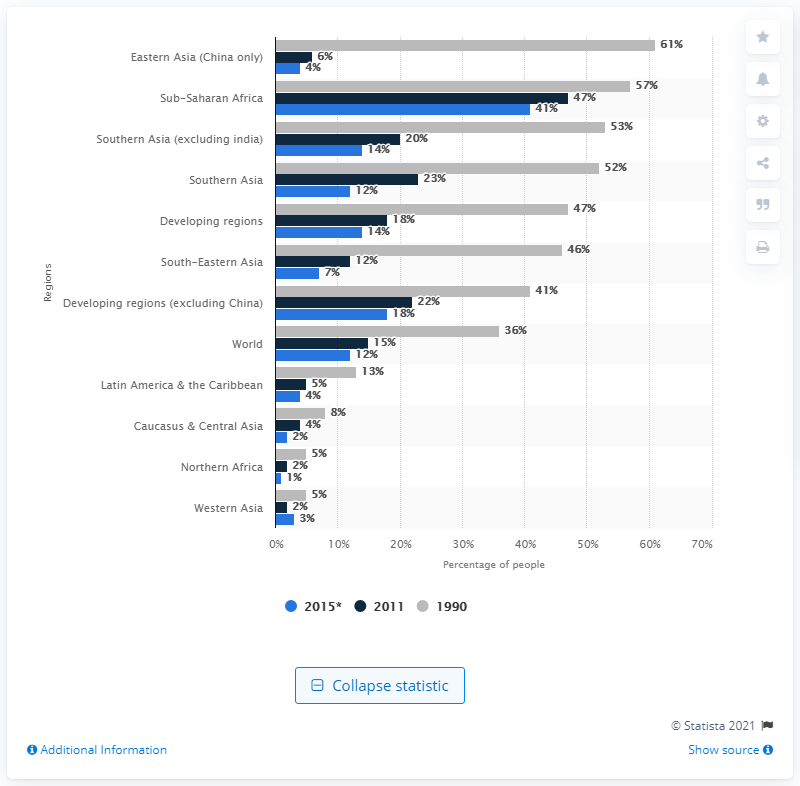Indicate a few pertinent items in this graphic. In 2011, approximately 47% of the population in sub-Saharan Africa lived on less than 1.25 U.S. dollars a day. Approximately 61% of the population in 1990 earned an income of less than $1.25 per day. 